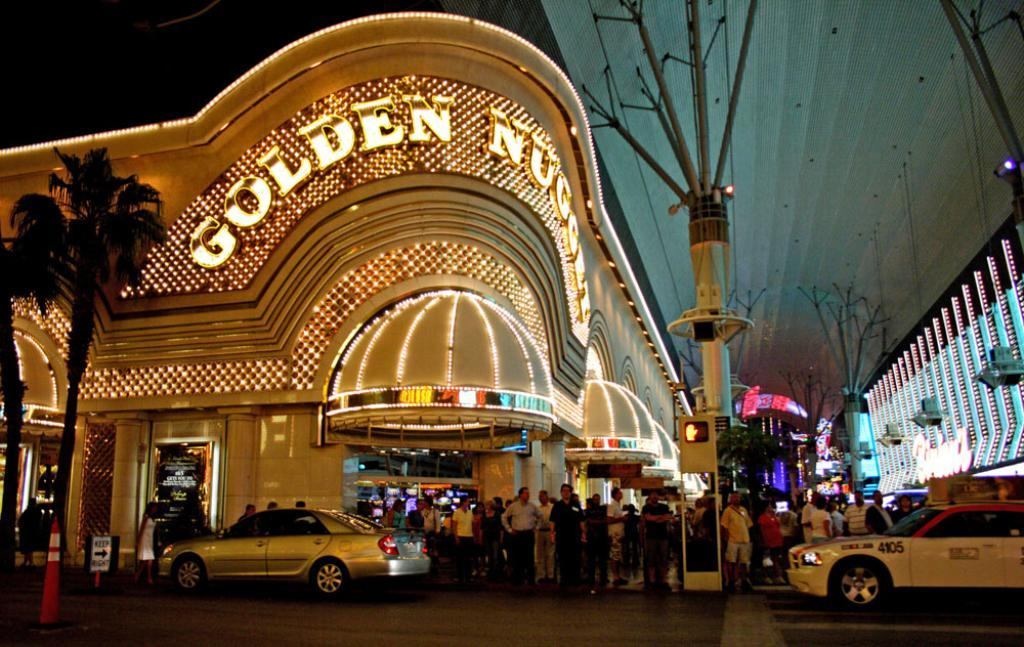<image>
Share a concise interpretation of the image provided. People gathered outside of the busy Golden Nugget casino. 